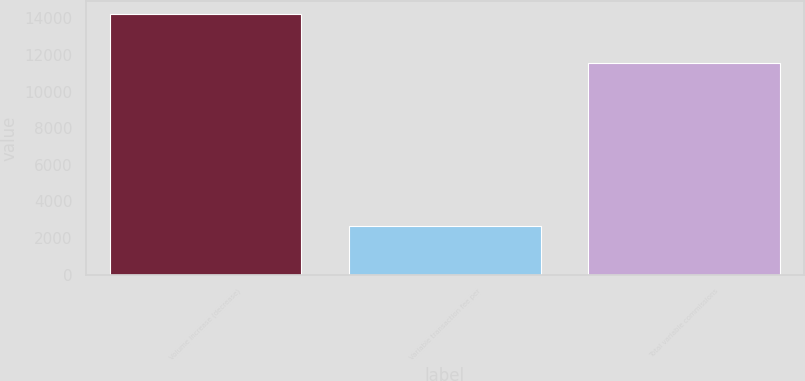<chart> <loc_0><loc_0><loc_500><loc_500><bar_chart><fcel>Volume increase (decrease)<fcel>Variable transaction fee per<fcel>Total variable commissions<nl><fcel>14229<fcel>2684<fcel>11545<nl></chart> 